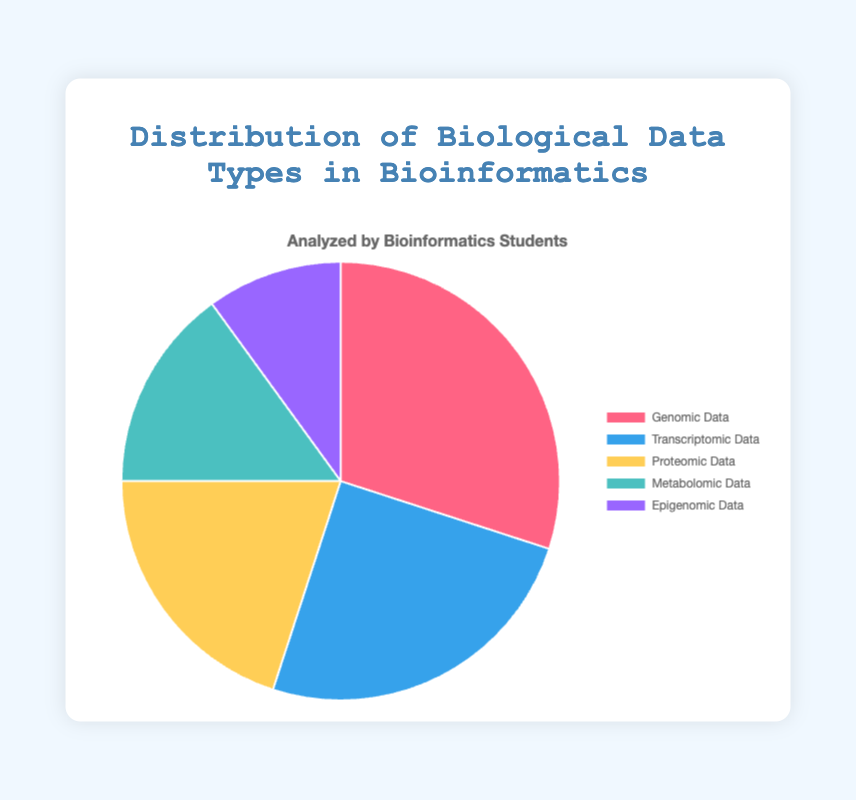What's the most frequently analyzed data type by bioinformatics students? The pie chart shows that Genomic Data has the largest slice, corresponding to the highest percentage value of 30%.
Answer: Genomic Data Which data type has the smallest percentage of analysis? Observing the pie chart, the smallest section belongs to Epigenomic Data which has a percentage of 10%.
Answer: Epigenomic Data What is the combined percentage of Proteomic Data and Metabolomic Data? The pie chart informs us that Proteomic Data is 20% and Metabolomic Data is 15%. Adding these values, 20% + 15%, gives a total of 35%.
Answer: 35% What is the difference in percentage between the highest and lowest analyzed data types? Genomic Data is the highest analyzed data type with 30%, and Epigenomic Data is the lowest with 10%. The difference is 30% - 10% = 20%.
Answer: 20% Which colors represent Proteomic Data and Transcriptomic Data respectively? According to the chart's legend, Proteomic Data is represented by the third slice, which is yellow, and Transcriptomic Data is the second slice, which is blue.
Answer: Yellow and blue Is the percentage of Genomic Data greater than that of Transcriptomic Data? From the pie chart, Genomic Data is 30% and Transcriptomic Data is 25%. Since 30% is greater than 25%, the answer is yes.
Answer: Yes What is the average percentage of all data types? The percentages provided are 30%, 25%, 20%, 15%, and 10%. Adding them we get 30% + 25% + 20% + 15% + 10% = 100%. Dividing by 5 data types, the average is 100% / 5 = 20%.
Answer: 20% What percentage of data is encompassed by types that have at least a 20% analysis rate? Genomic Data (30%) and Transcriptomic Data (25%) both meet this criterion. Their combined percentage is 30% + 25% = 55%.
Answer: 55% Which data type categories combined are equal to the percentage of Genomic Data? The individual categories are Transcriptomic (25%) and Epigenomic (10%). Together, they sum to 35%, which is not equal. However, Metabolomic (15%) plus Proteomic (20%) equals 35%, also not equal. Thus, no exact match other than comparing with itself.
Answer: None 